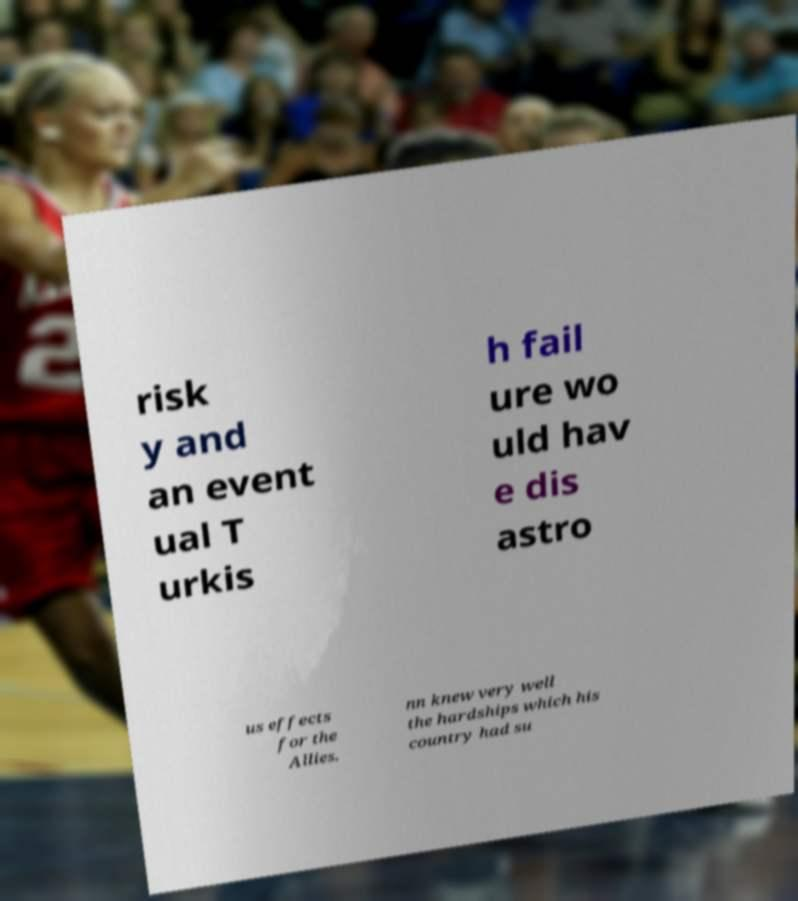Could you assist in decoding the text presented in this image and type it out clearly? risk y and an event ual T urkis h fail ure wo uld hav e dis astro us effects for the Allies. nn knew very well the hardships which his country had su 